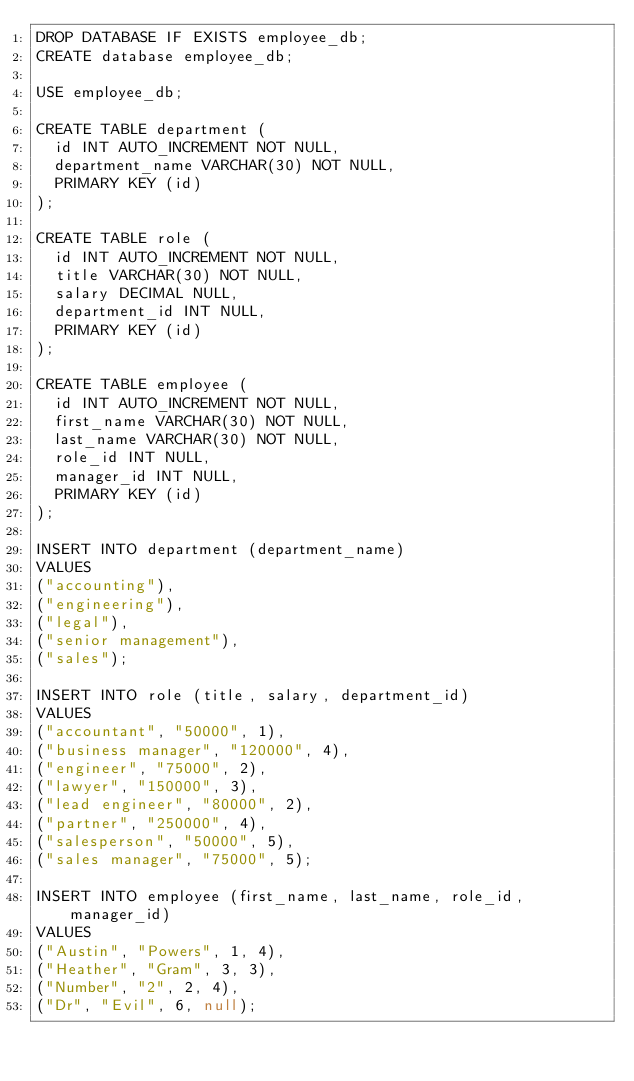<code> <loc_0><loc_0><loc_500><loc_500><_SQL_>DROP DATABASE IF EXISTS employee_db;
CREATE database employee_db;

USE employee_db;

CREATE TABLE department (
  id INT AUTO_INCREMENT NOT NULL,
  department_name VARCHAR(30) NOT NULL,
  PRIMARY KEY (id)
);

CREATE TABLE role (
  id INT AUTO_INCREMENT NOT NULL,
  title VARCHAR(30) NOT NULL,
  salary DECIMAL NULL,
  department_id INT NULL,
  PRIMARY KEY (id)
);

CREATE TABLE employee (
  id INT AUTO_INCREMENT NOT NULL,
  first_name VARCHAR(30) NOT NULL,
  last_name VARCHAR(30) NOT NULL,
  role_id INT NULL,
  manager_id INT NULL,
  PRIMARY KEY (id)
);

INSERT INTO department (department_name)
VALUES 
("accounting"),
("engineering"),
("legal"),
("senior management"),
("sales");

INSERT INTO role (title, salary, department_id)
VALUES 
("accountant", "50000", 1),
("business manager", "120000", 4),
("engineer", "75000", 2),
("lawyer", "150000", 3),
("lead engineer", "80000", 2),
("partner", "250000", 4),
("salesperson", "50000", 5),
("sales manager", "75000", 5);

INSERT INTO employee (first_name, last_name, role_id, manager_id)
VALUES
("Austin", "Powers", 1, 4),
("Heather", "Gram", 3, 3),
("Number", "2", 2, 4),
("Dr", "Evil", 6, null);</code> 